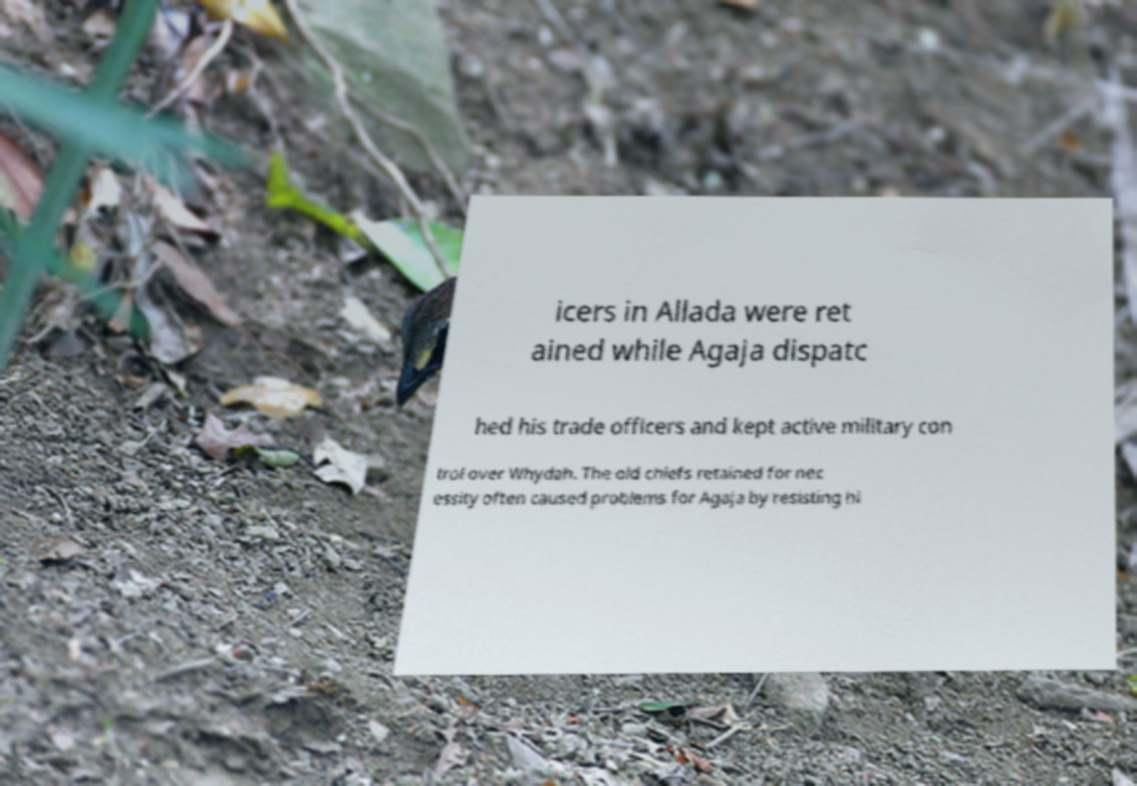I need the written content from this picture converted into text. Can you do that? icers in Allada were ret ained while Agaja dispatc hed his trade officers and kept active military con trol over Whydah. The old chiefs retained for nec essity often caused problems for Agaja by resisting hi 